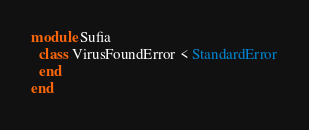<code> <loc_0><loc_0><loc_500><loc_500><_Ruby_>module Sufia
  class VirusFoundError < StandardError
  end
end
</code> 